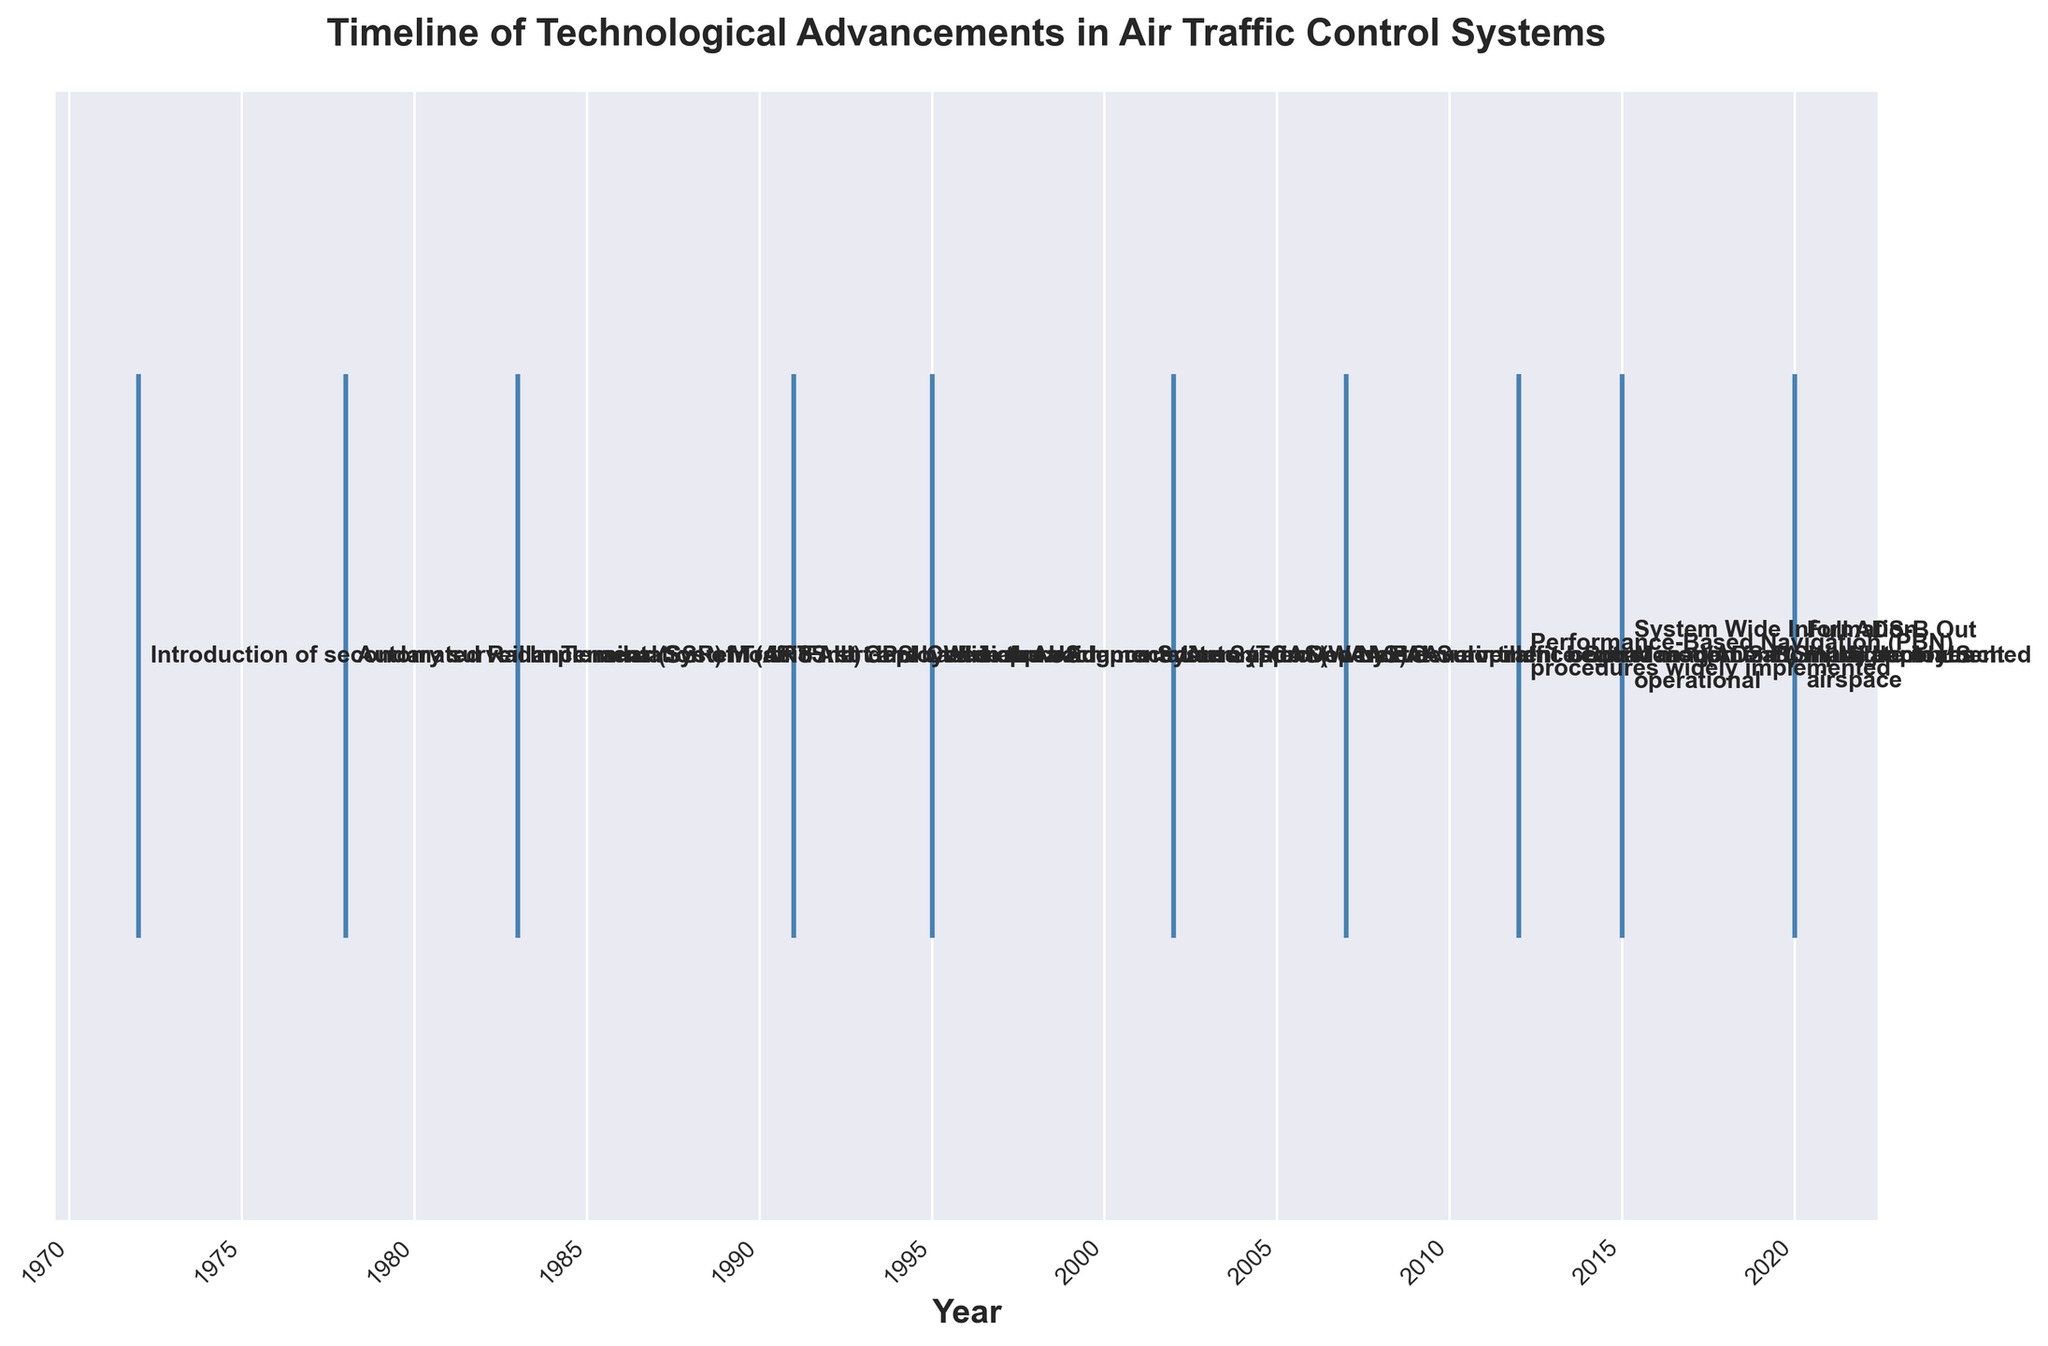What is the title of the figure? The title of the figure is usually displayed at the top or in a prominent location in larger fonts. It provides an overview or main topic of the figure.
Answer: Timeline of Technological Advancements in Air Traffic Control Systems How many events are plotted in the figure? We can count the number of points or annotations on the x-axis to determine the number of events shown.
Answer: 10 What is the earliest technological advancement mentioned in the plot? The earliest event is the first one on the leftmost side of the x-axis, indicating the start of the timeline.
Answer: Introduction of secondary surveillance radar (SSR) Mode S in 1972 What significant event occurred in 1983? Refer to the annotations along the timeline to find the event closest to or exactly at the year 1983.
Answer: Implementation of Traffic Alert and Collision Avoidance System (TCAS) What is the difference in years between the launch of NextGen air traffic control modernization program and the initial deployment of ADS-B? Identify the years for both events and subtract them to find the difference. NextGen was launched in 2007 and ADS-B was initially deployed in 2002.
Answer: 5 years Which event occurred in 2020 and what was its significance? Find the annotation near or exactly at the year 2020 on the timeline and read the event description.
Answer: Full ADS-B Out mandate in US airspace Between the years 2002 and 2012, which technological advancements were implemented according to the figure? Look for annotations between the years 2002 and 2012 and list all events within this range.
Answer: Automatic Dependent Surveillance-Broadcast (ADS-B) initial deployment in 2002, NextGen air traffic control modernization program launched in 2007, and Performance-Based Navigation (PBN) procedures widely implemented in 2012 Compare the spacing of events between 1991 and 2002 to the spacing between 2007 and 2020. Which period saw more rapid advancements in air traffic control systems? Count the number of events in each given period and compare their densities based on the number of years involved. 1991-2002 includes GPS-based approach procedures (1991), WAAS development (1995), and ADS-B initial deployment (2002). 2007-2020 includes NextGen launch (2007), PBN procedures (2012), SWIM operational (2015), and ADS-B Out mandate (2020).
Answer: 2007-2020 What year did the Wide Area Augmentation System (WAAS) development begin? Find the annotation on the timeline related to WAAS development.
Answer: 1995 